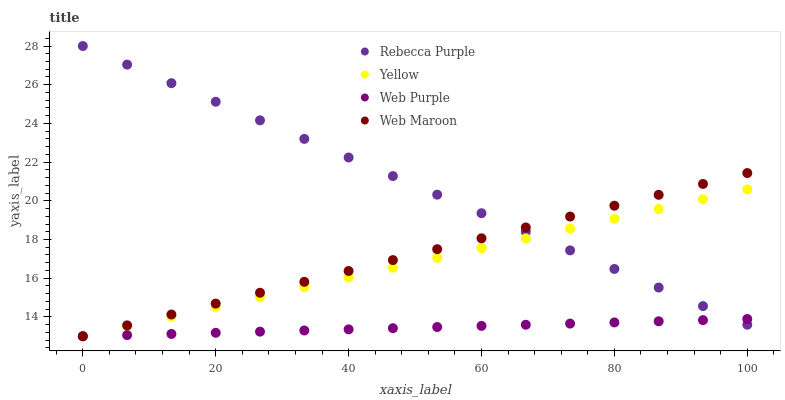Does Web Purple have the minimum area under the curve?
Answer yes or no. Yes. Does Rebecca Purple have the maximum area under the curve?
Answer yes or no. Yes. Does Web Maroon have the minimum area under the curve?
Answer yes or no. No. Does Web Maroon have the maximum area under the curve?
Answer yes or no. No. Is Web Purple the smoothest?
Answer yes or no. Yes. Is Web Maroon the roughest?
Answer yes or no. Yes. Is Rebecca Purple the smoothest?
Answer yes or no. No. Is Rebecca Purple the roughest?
Answer yes or no. No. Does Web Purple have the lowest value?
Answer yes or no. Yes. Does Rebecca Purple have the lowest value?
Answer yes or no. No. Does Rebecca Purple have the highest value?
Answer yes or no. Yes. Does Web Maroon have the highest value?
Answer yes or no. No. Does Web Maroon intersect Yellow?
Answer yes or no. Yes. Is Web Maroon less than Yellow?
Answer yes or no. No. Is Web Maroon greater than Yellow?
Answer yes or no. No. 